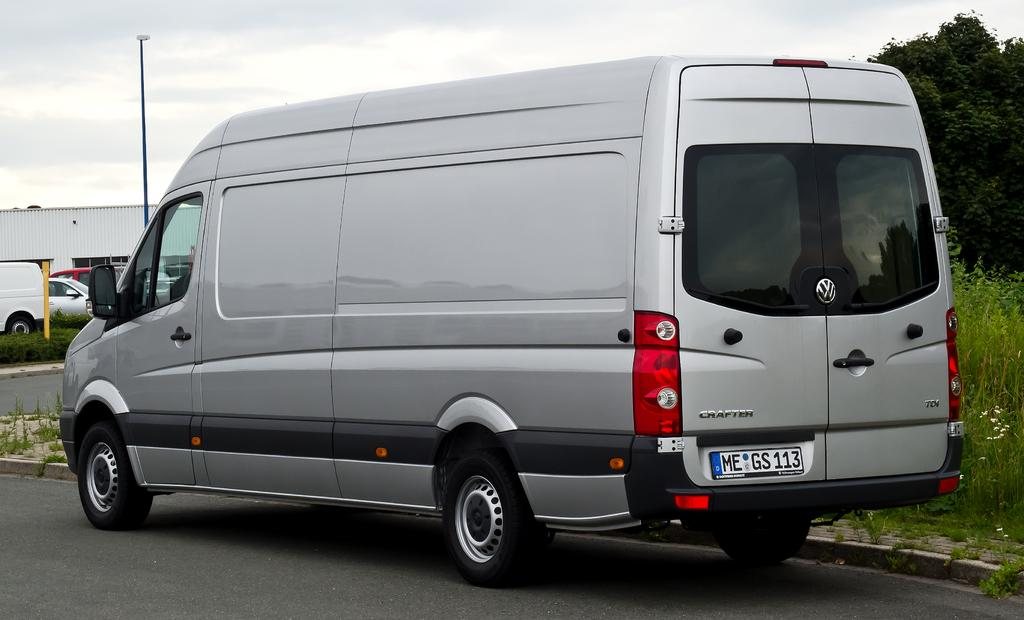<image>
Describe the image concisely. A gray crafter van parked on the street. 